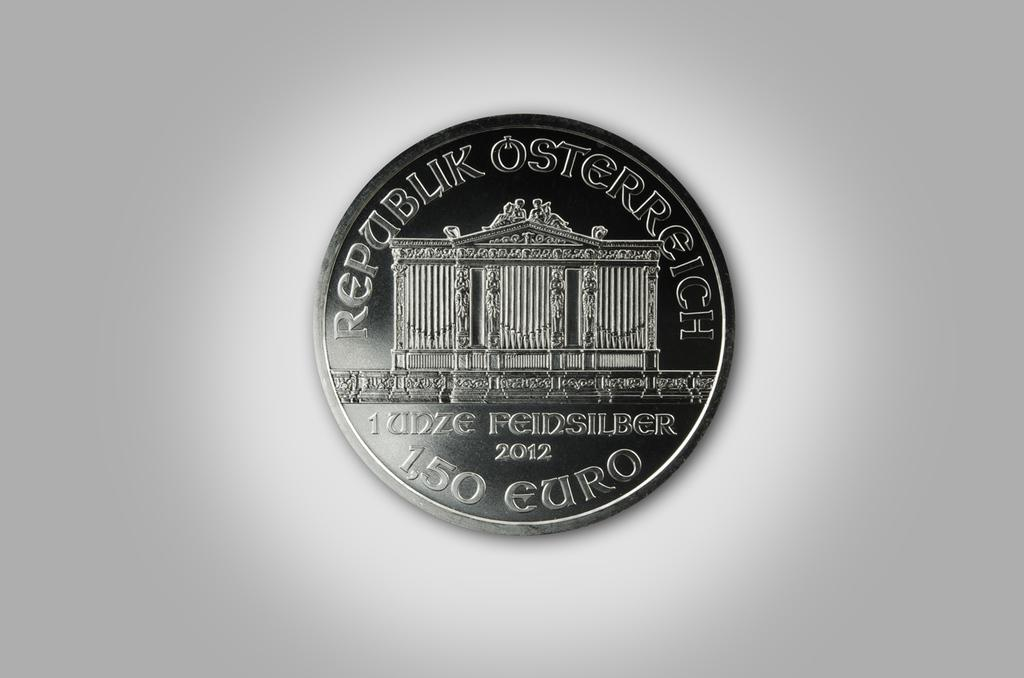<image>
Present a compact description of the photo's key features. A foreign coin made in 2012 has the value of 1.50 Euro. 